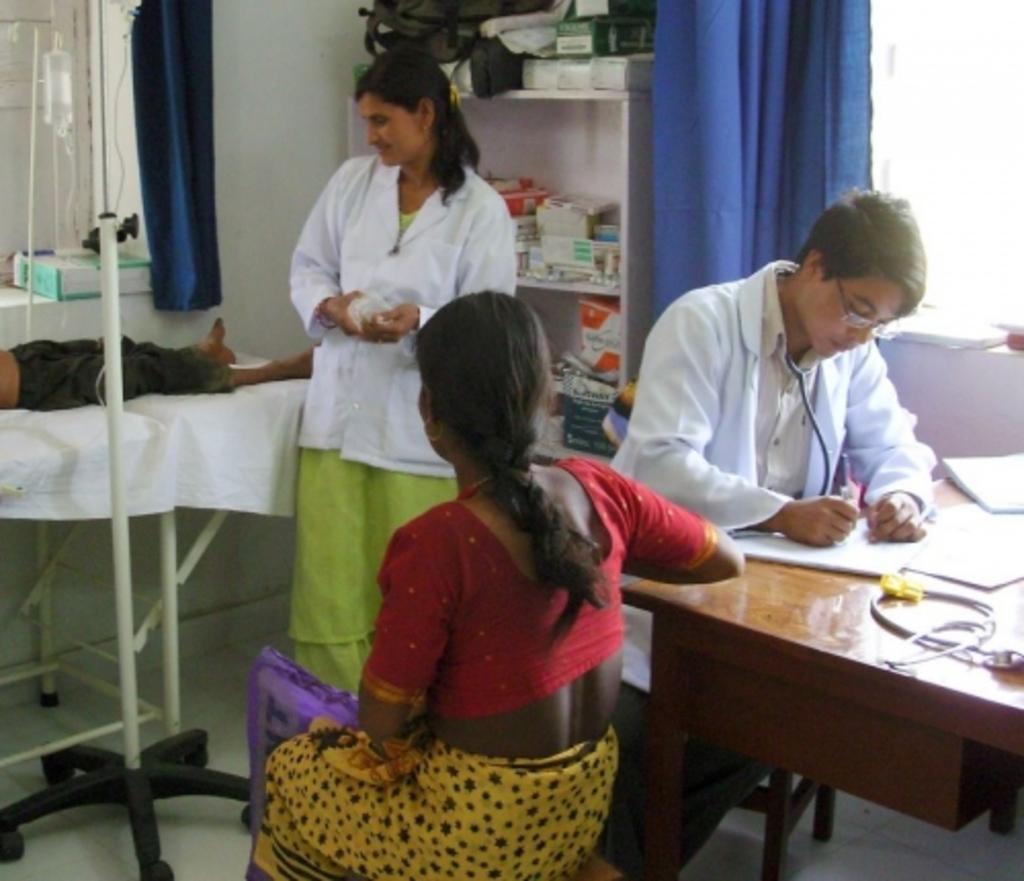Describe this image in one or two sentences. In this image there are four persons. He is a doctor. she is a nurse and a patient. On the bed there is a person lying. There is a saline bottle and a stand. Table contain paper,stethoscope. There is rack in which there are medicine boxes. On the top of the rock there is bag. The room contain window and a curtain. 